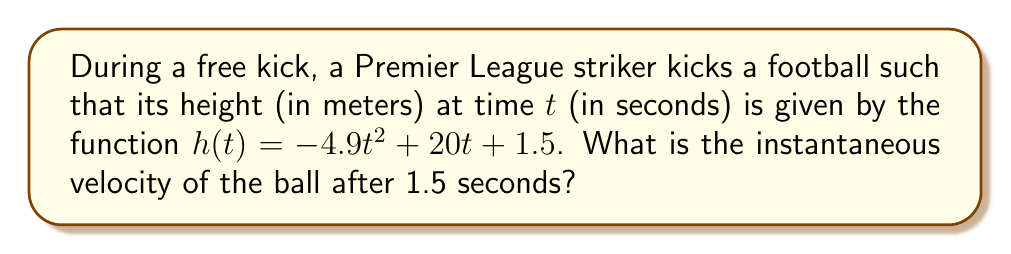Can you solve this math problem? To find the instantaneous velocity, we need to calculate the derivative of the height function and evaluate it at t = 1.5 seconds.

Step 1: Find the derivative of h(t).
The height function is $h(t) = -4.9t^2 + 20t + 1.5$
The derivative is $h'(t) = -9.8t + 20$

Step 2: Evaluate the derivative at t = 1.5 seconds.
$h'(1.5) = -9.8(1.5) + 20$
$h'(1.5) = -14.7 + 20$
$h'(1.5) = 5.3$

The instantaneous velocity is the value of the derivative at the given time. Therefore, the instantaneous velocity of the football after 1.5 seconds is 5.3 m/s.
Answer: 5.3 m/s 